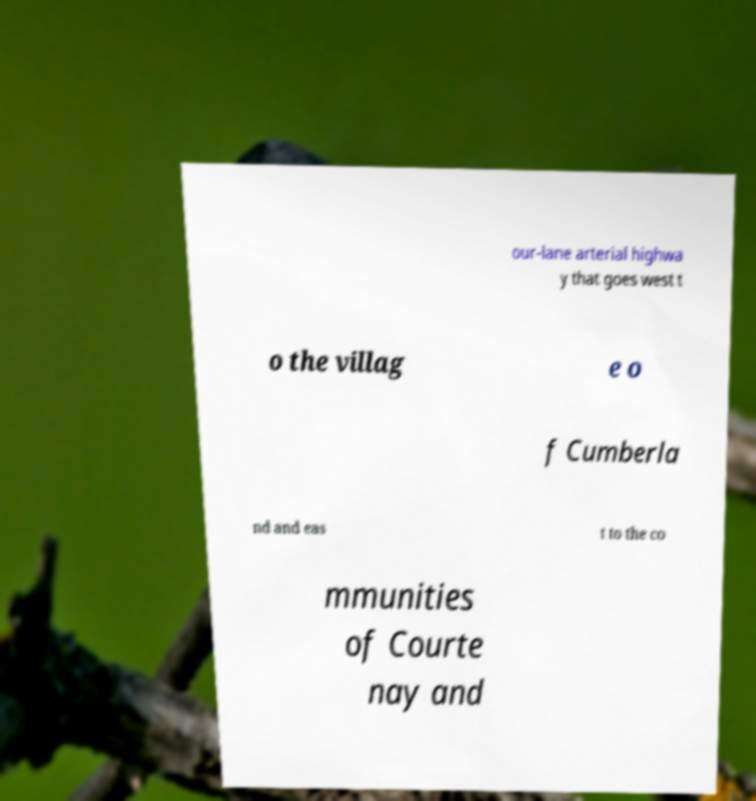I need the written content from this picture converted into text. Can you do that? our-lane arterial highwa y that goes west t o the villag e o f Cumberla nd and eas t to the co mmunities of Courte nay and 